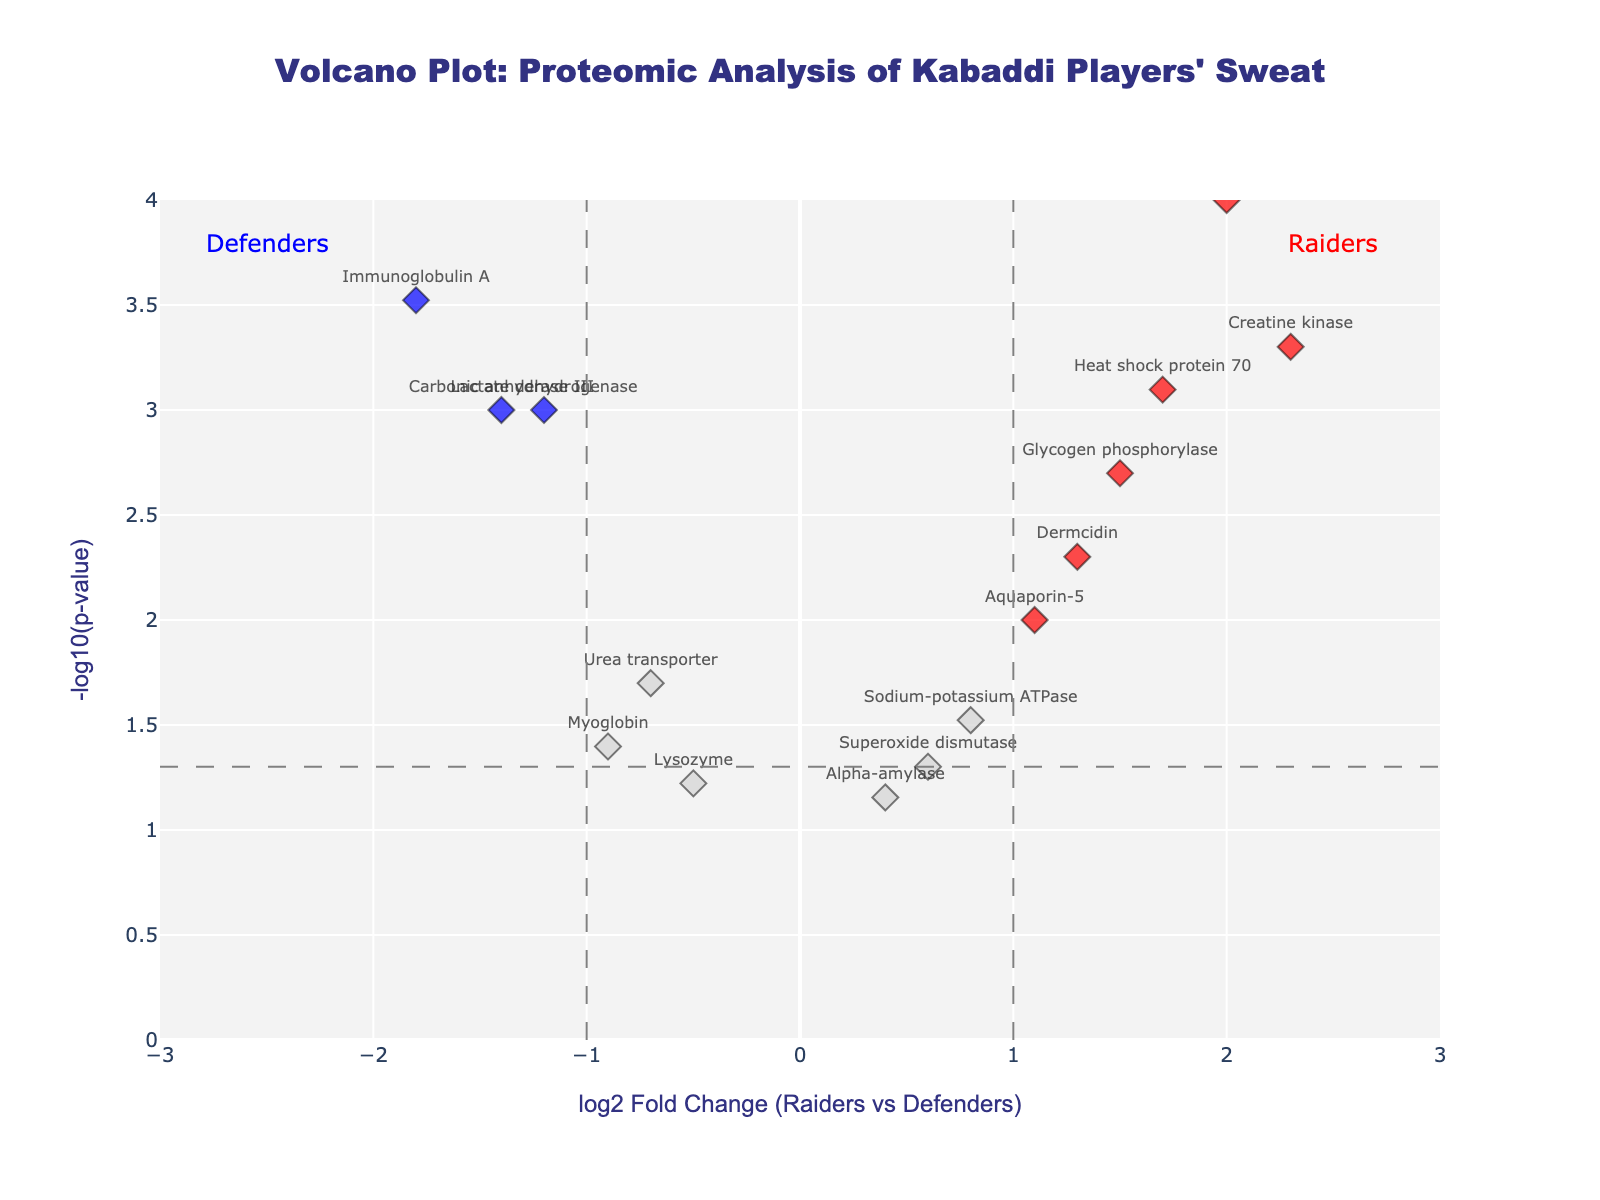What is the title of the plot? The title of the plot is displayed at the top center of the figure. It reads "Volcano Plot: Proteomic Analysis of Kabaddi Players' Sweat".
Answer: Volcano Plot: Proteomic Analysis of Kabaddi Players' Sweat How many data points are displayed in the plot? To find the number of data points, count the number of markers on the plot. Each protein is represented by one marker, so there are as many data points as there are proteins listed. There are 15 proteins listed in the data.
Answer: 15 Which protein shows the highest log2 fold change? By looking at the x-axis, find the protein with the highest log2 fold change. This is the point farthest to the right. Matrix metalloproteinase-9 has the highest log2 fold change of 2.0.
Answer: Matrix metalloproteinase-9 What color represents significantly increased proteins in Raiders? Significantly increased proteins are above the fold change threshold and below the p-value threshold. These proteins are marked in red as indicated by the custom color scale and the annotations.
Answer: Red Which protein has the lowest p-value? The p-value can be deduced from the y-axis values as -log10(p-value), meaning higher y-values indicate lower p-values. The highest point on the y-axis refers to the lowest p-value. Matrix metalloproteinase-9 has the highest y-value of approximately 4 (since -log10(0.0001) = 4), indicating the lowest p-value of 0.0001.
Answer: Matrix metalloproteinase-9 Which proteins are considered significantly more abundant in Defenders? To find these proteins, identify points that are marked in blue (indicating significant decrease) and have a log2 fold change less than -1 and a p-value less than 0.05. The proteins are Lactate dehydrogenase (-1.2, 0.001), Carbonic anhydrase III (-1.4, 0.001), and Immunoglobulin A (-1.8, 0.0003).
Answer: Lactate dehydrogenase, Carbonic anhydrase III, Immunoglobulin A How many proteins have a log2 fold change greater than 1 but less significant with a p-value greater than 0.05? Find the proteins on the plot with a log2 fold change greater than 1 and a y-axis value below -log10(0.05). None of the proteins in the plot match these criteria.
Answer: 0 For proteins with log2 fold change between -1 and 1, how many have p-values greater than 0.05? Look for proteins with -1 < log2 fold change < 1 and determine if they are below the -log10(p-value) threshold of 1.3 (since -log10(0.05) ≈ 1.3). The proteins are Lysozyme (-0.5, 0.06) and Alpha-amylase (0.4, 0.07).
Answer: 2 Which proteins are located close to the threshold lines? Identify proteins near the vertical and horizontal threshold lines. Sodium-potassium ATPase and Urea transporter are nearest to the p-value horizontal threshold line, and Glycogen phosphorylase and Myoglobin are near the log2 fold change vertical thresholds.
Answer: Sodium-potassium ATPase, Urea transporter, Glycogen phosphorylase, Myoglobin 